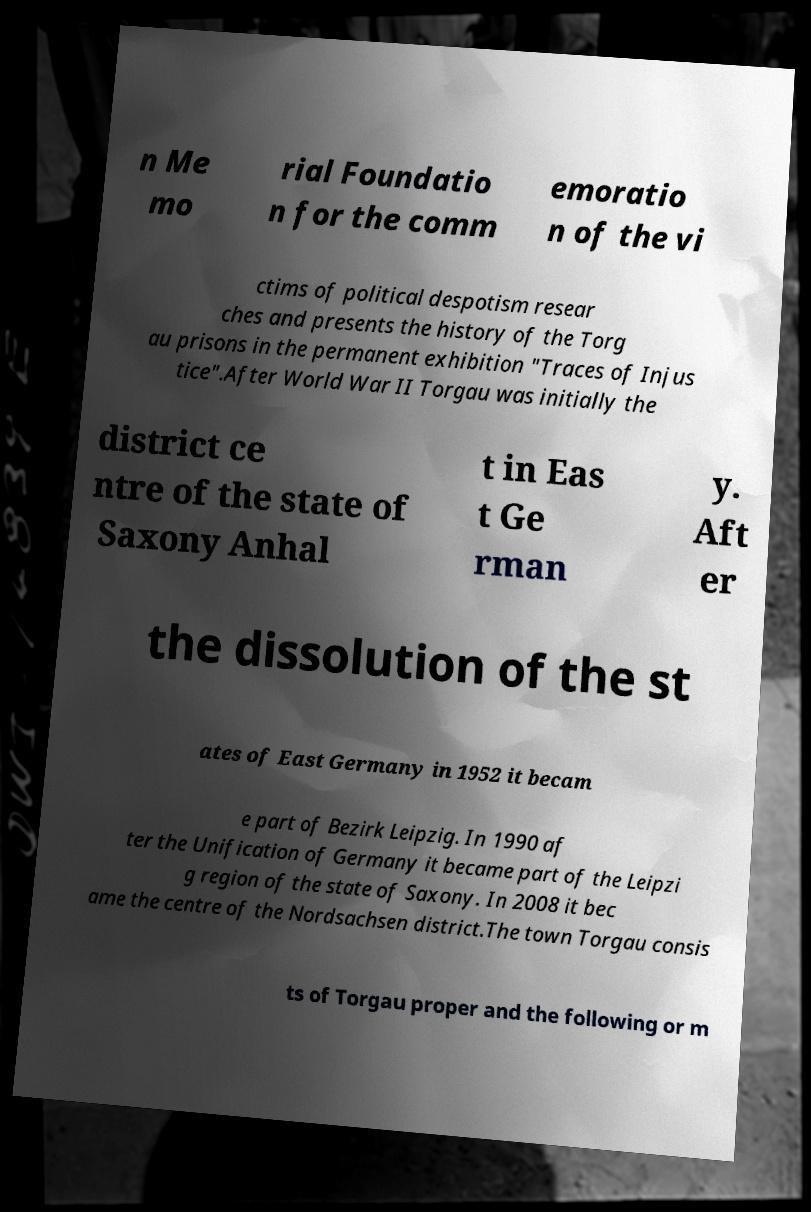Can you read and provide the text displayed in the image?This photo seems to have some interesting text. Can you extract and type it out for me? n Me mo rial Foundatio n for the comm emoratio n of the vi ctims of political despotism resear ches and presents the history of the Torg au prisons in the permanent exhibition "Traces of Injus tice".After World War II Torgau was initially the district ce ntre of the state of Saxony Anhal t in Eas t Ge rman y. Aft er the dissolution of the st ates of East Germany in 1952 it becam e part of Bezirk Leipzig. In 1990 af ter the Unification of Germany it became part of the Leipzi g region of the state of Saxony. In 2008 it bec ame the centre of the Nordsachsen district.The town Torgau consis ts of Torgau proper and the following or m 